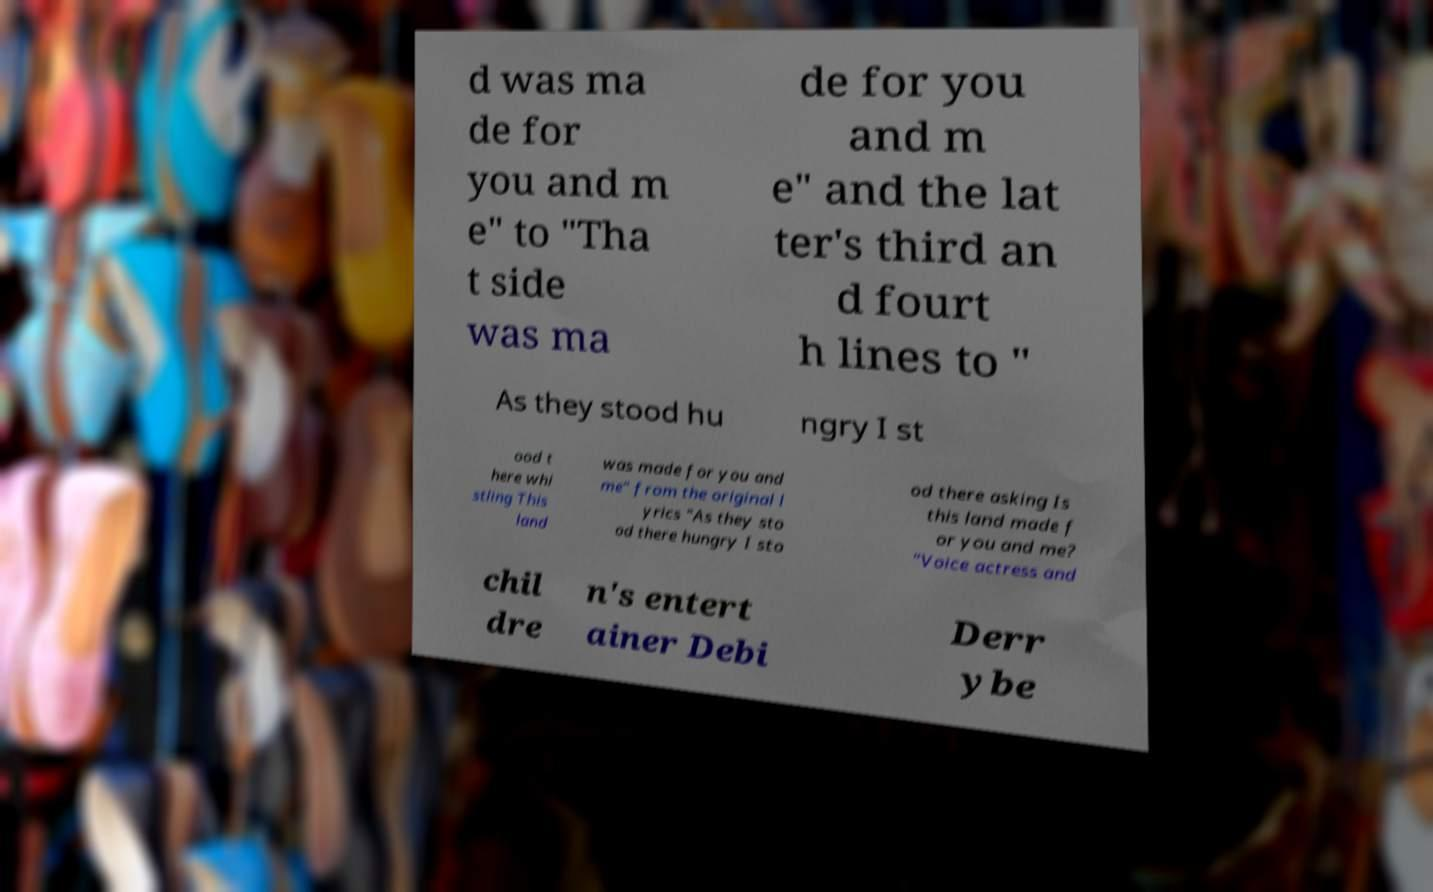Please identify and transcribe the text found in this image. d was ma de for you and m e" to "Tha t side was ma de for you and m e" and the lat ter's third an d fourt h lines to " As they stood hu ngry I st ood t here whi stling This land was made for you and me" from the original l yrics "As they sto od there hungry I sto od there asking Is this land made f or you and me? "Voice actress and chil dre n's entert ainer Debi Derr ybe 